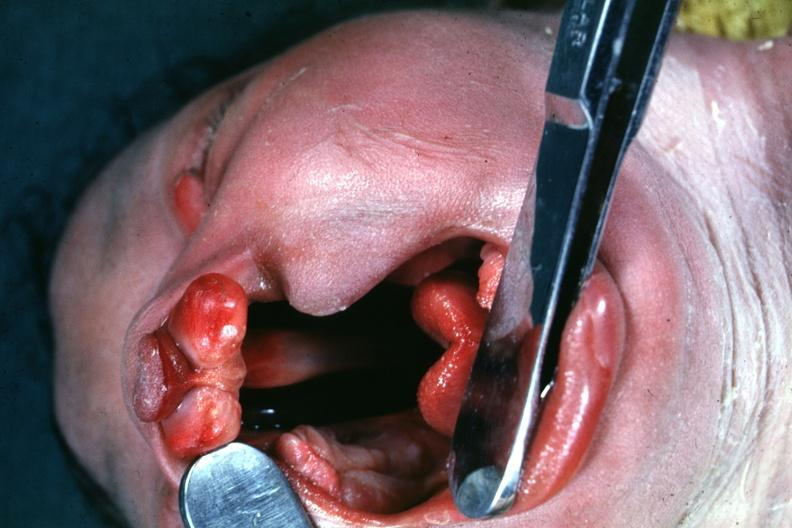what is head tilted with mouth opened?
Answer the question using a single word or phrase. To show large defect very good illustration of this lesion 